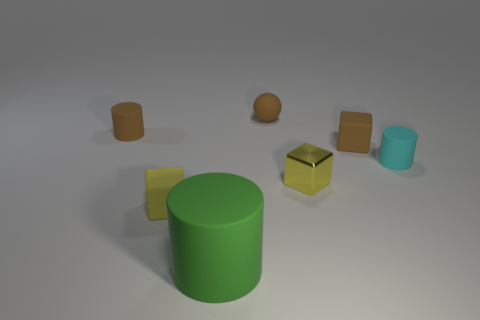What number of tiny rubber blocks are the same color as the metallic cube?
Offer a terse response. 1. What number of objects are either cyan balls or brown matte objects that are on the left side of the small yellow matte cube?
Give a very brief answer. 1. Is the size of the rubber cylinder that is right of the rubber ball the same as the block that is right of the yellow metallic cube?
Your response must be concise. Yes. Is there a thing made of the same material as the big cylinder?
Ensure brevity in your answer.  Yes. What shape is the metallic thing?
Make the answer very short. Cube. There is a small brown thing behind the tiny cylinder to the left of the tiny yellow rubber block; what is its shape?
Offer a very short reply. Sphere. How many other things are there of the same shape as the large green rubber object?
Ensure brevity in your answer.  2. There is a brown thing that is behind the cylinder behind the tiny brown rubber cube; how big is it?
Keep it short and to the point. Small. Are any green matte cylinders visible?
Your answer should be compact. Yes. There is a small cube that is to the left of the big rubber object; what number of brown rubber spheres are left of it?
Keep it short and to the point. 0. 